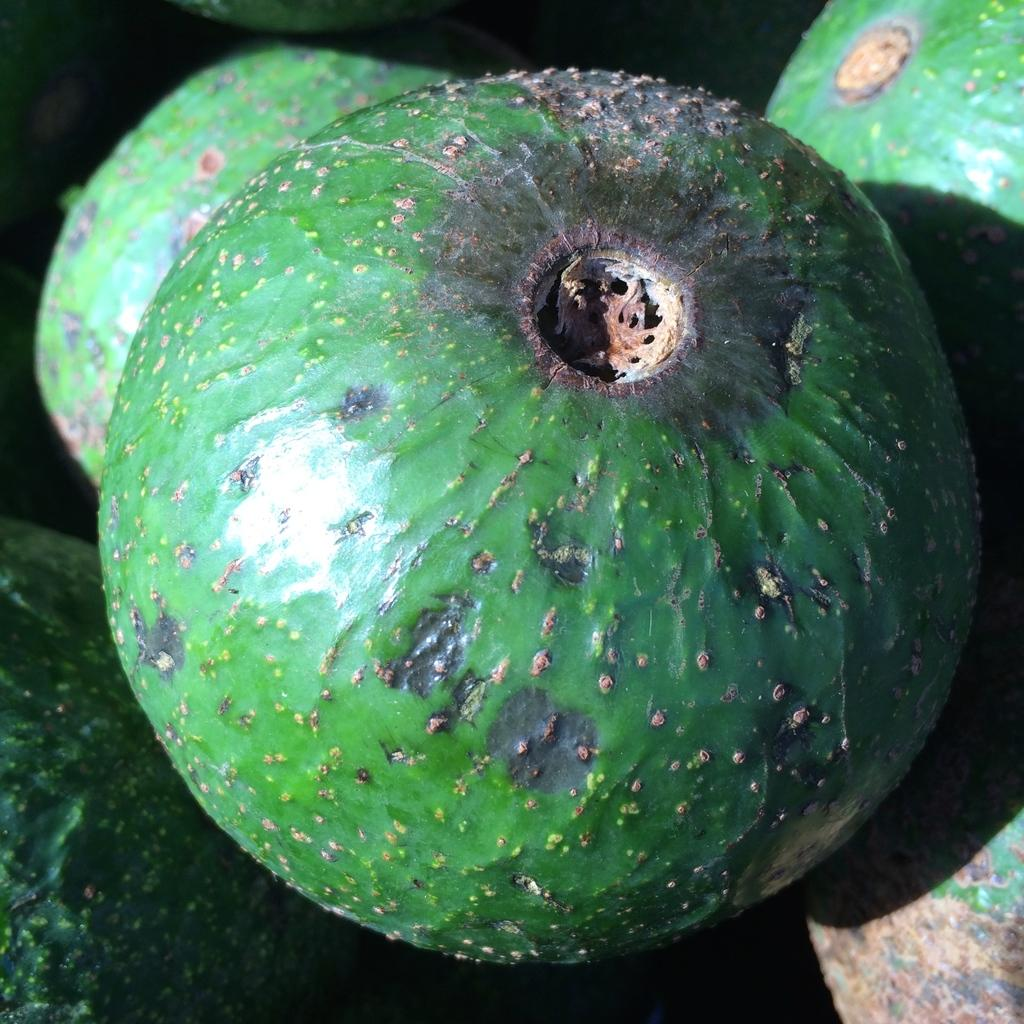What is the main subject of the image? The main subject of the image is green color objects. What is the color of the objects in the center of the image? The objects in the center of the image are green. What might the green color objects be? The green color objects seem to be fruits. How many trucks are parked next to the green color objects in the image? There are no trucks present in the image; it only features green color objects that seem to be fruits. 